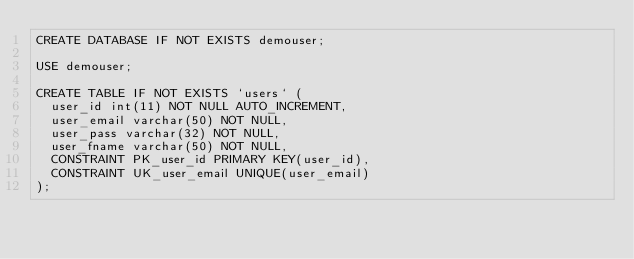Convert code to text. <code><loc_0><loc_0><loc_500><loc_500><_SQL_>CREATE DATABASE IF NOT EXISTS demouser;

USE demouser;

CREATE TABLE IF NOT EXISTS `users` (
	user_id int(11) NOT NULL AUTO_INCREMENT,
	user_email varchar(50) NOT NULL,
	user_pass varchar(32) NOT NULL,
	user_fname varchar(50) NOT NULL,
	CONSTRAINT PK_user_id PRIMARY KEY(user_id),
	CONSTRAINT UK_user_email UNIQUE(user_email)
);
</code> 